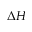Convert formula to latex. <formula><loc_0><loc_0><loc_500><loc_500>\Delta H</formula> 